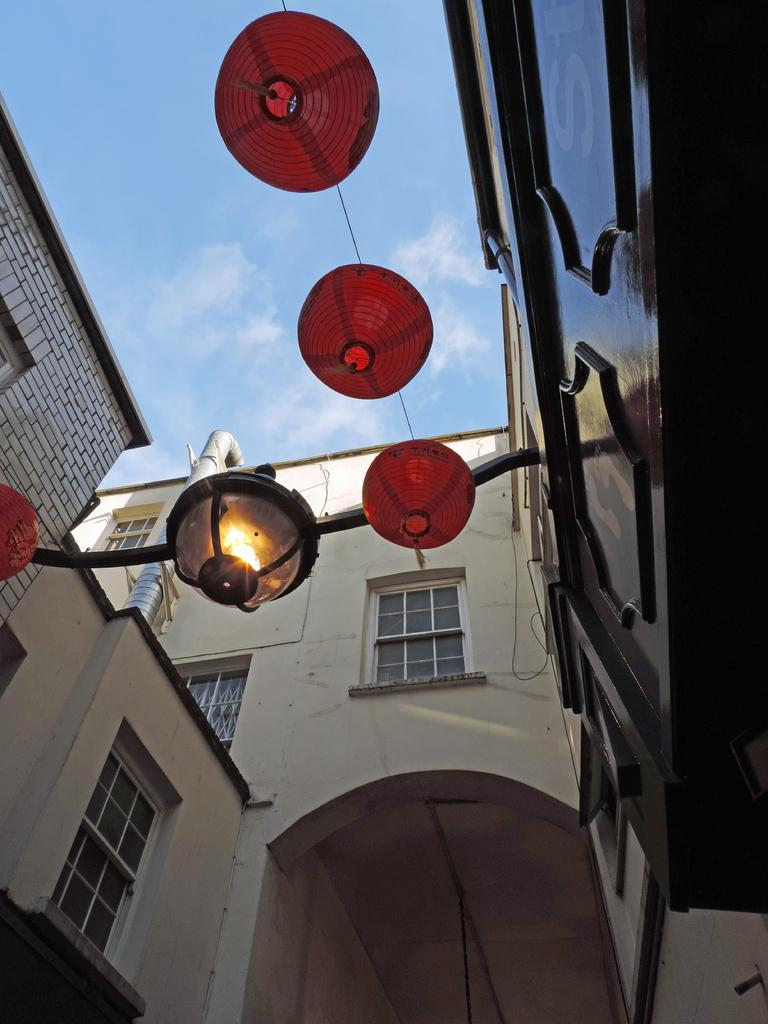What type of structures can be seen in the image? There are buildings in the image. What is located in the center of the image? There are lights in the center of the image. What is visible at the top of the image? The sky is visible at the top of the image. What type of prose is being recited by the buildings in the image? There is no indication in the image that the buildings are reciting any prose. What kind of meal is being prepared in the image? There is no meal preparation visible in the image. 